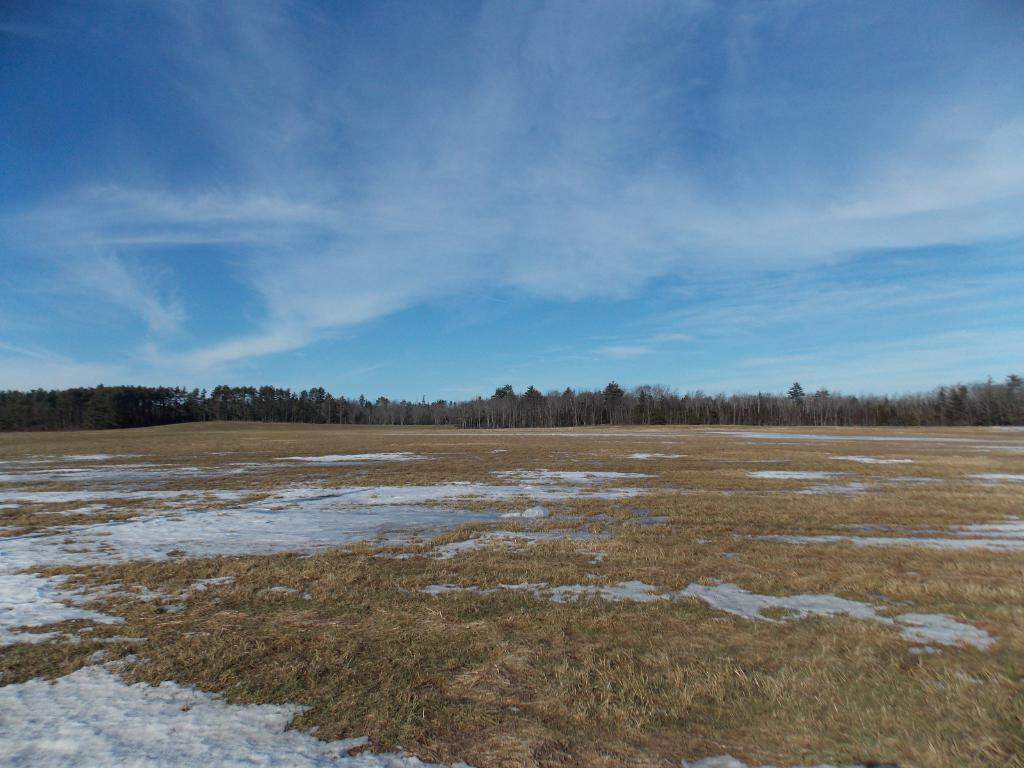What type of terrain is visible in the image? There is land with dry grass in the image. What type of vegetation can be seen in the image? Trees are present in the image. What is visible in the sky in the image? Clouds are visible at the top of the image. What type of stamp can be seen on the pig in the image? There is no pig or stamp present in the image. 